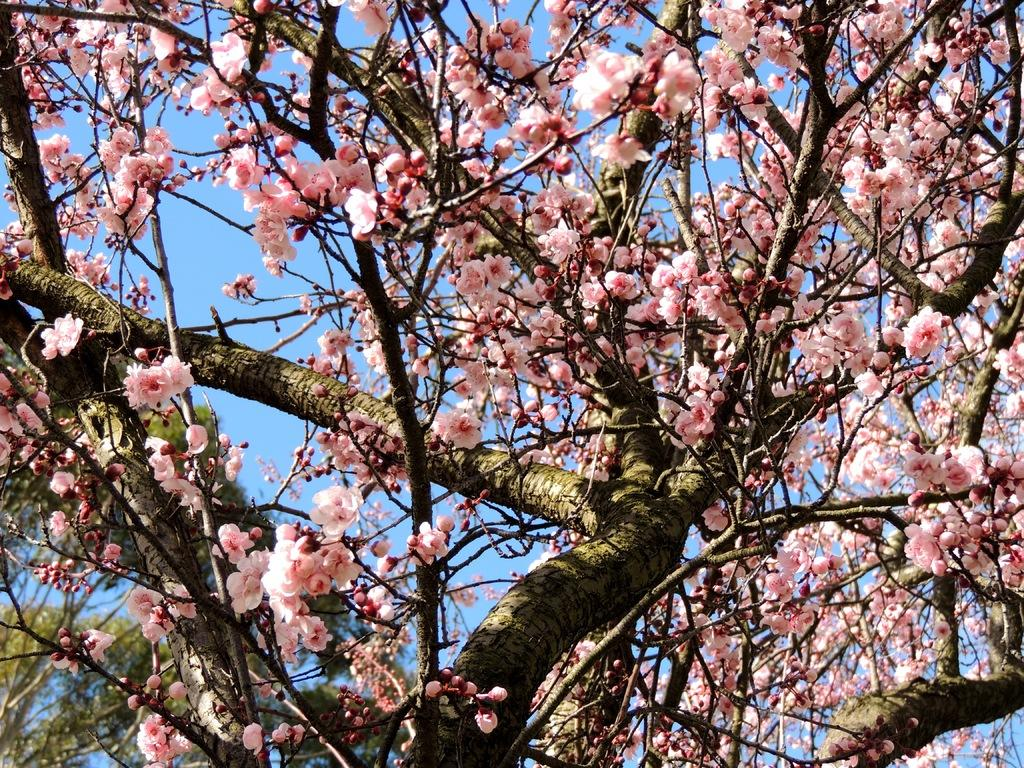What type of plant can be seen in the image? There is a tree in the image. What features of the tree are visible? The tree has branches and flowers. What color are the flowers on the tree? The flowers on the tree are pale peach in color. What can be seen in the background of the image? The sky is visible in the image and is blue. What type of system does the tree use to achieve photosynthesis? The image does not provide information about the tree's photosynthesis system or its achievements. 